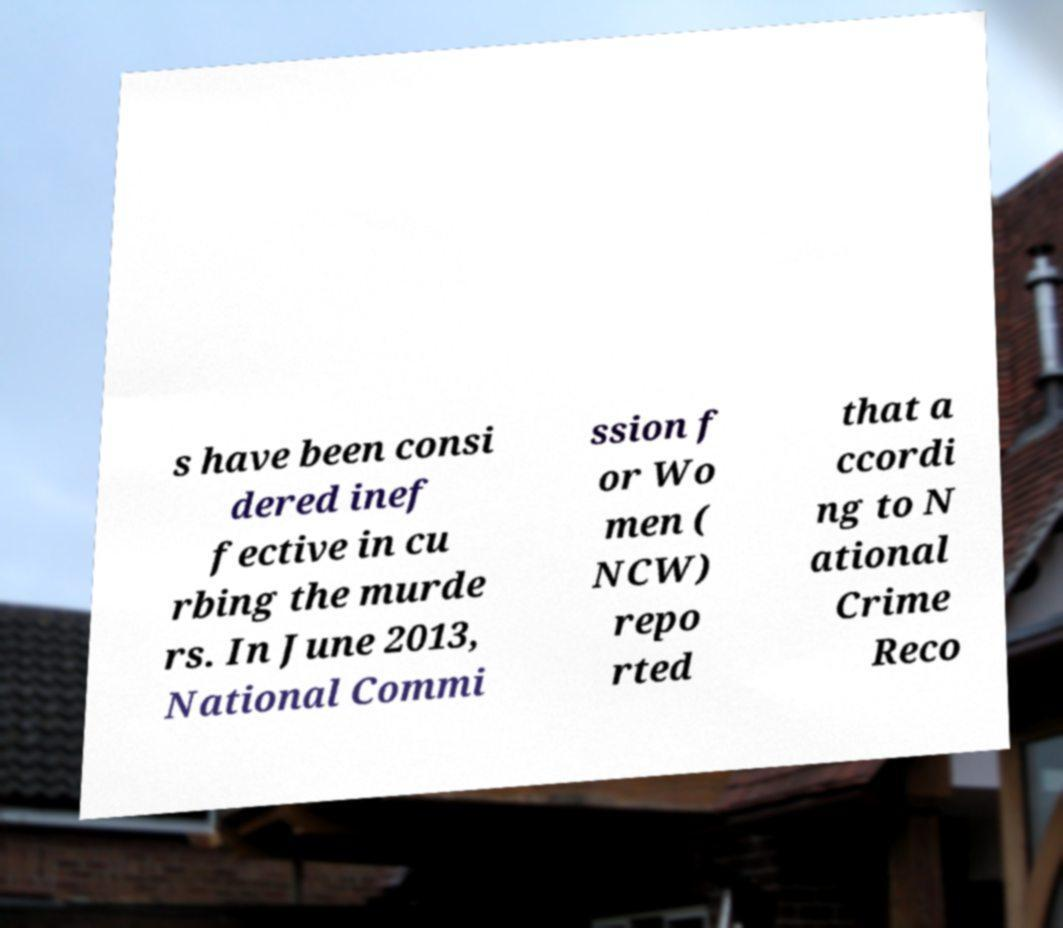Can you accurately transcribe the text from the provided image for me? s have been consi dered inef fective in cu rbing the murde rs. In June 2013, National Commi ssion f or Wo men ( NCW) repo rted that a ccordi ng to N ational Crime Reco 